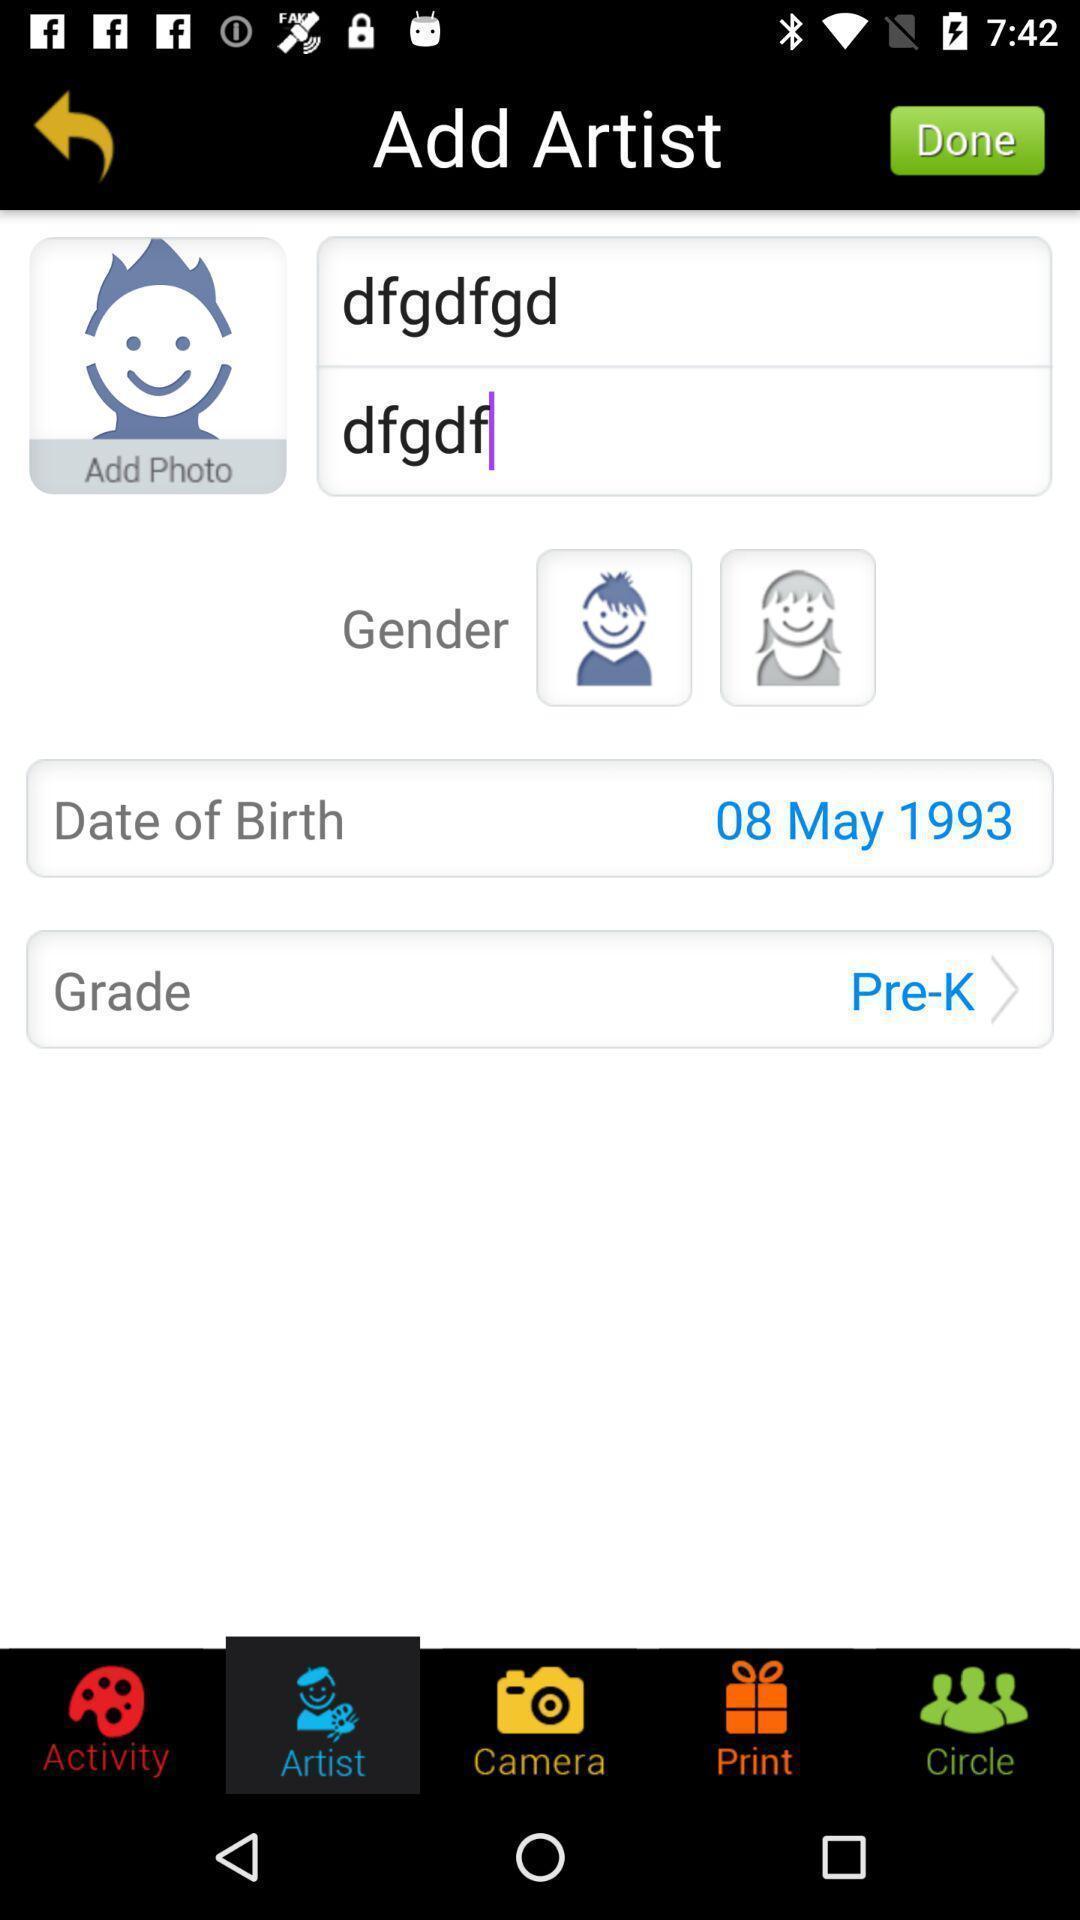Tell me what you see in this picture. Page for adding artist to children artwork app. 